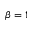Convert formula to latex. <formula><loc_0><loc_0><loc_500><loc_500>\beta = 1</formula> 